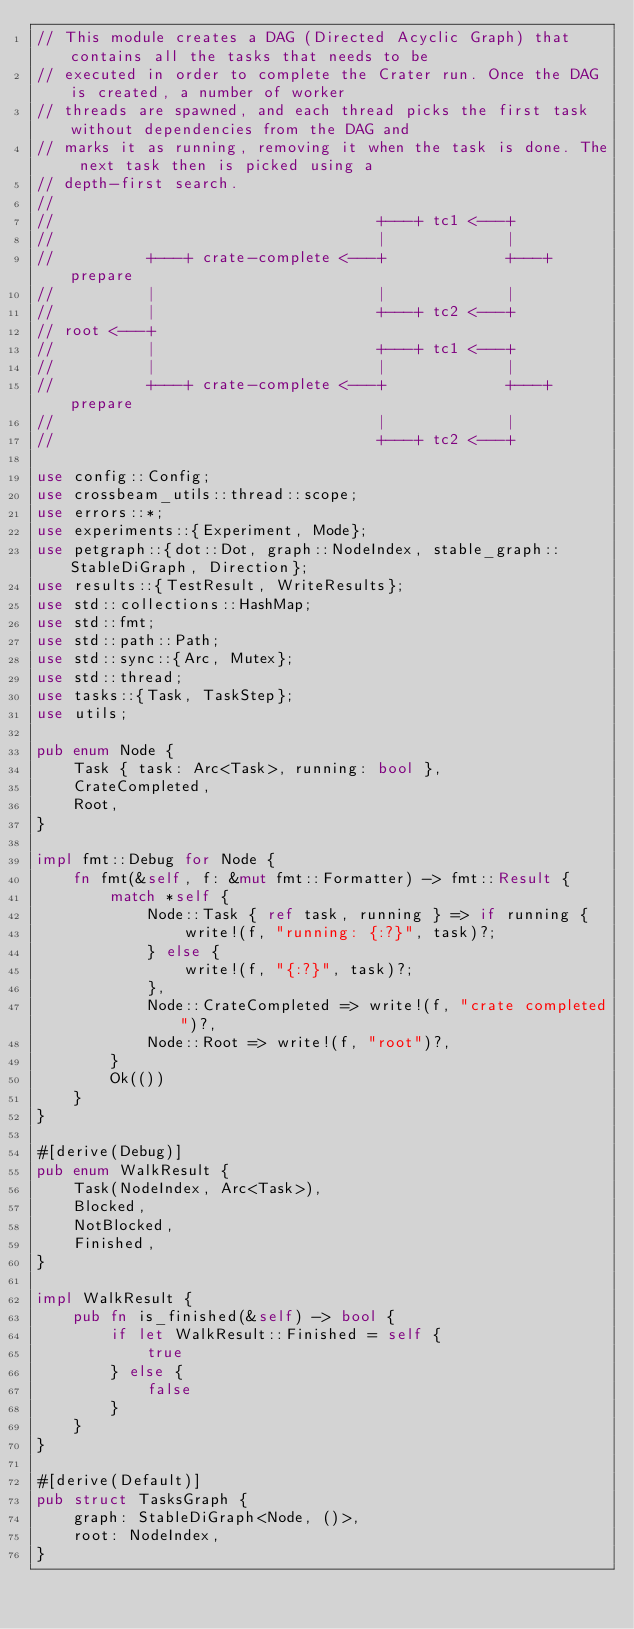<code> <loc_0><loc_0><loc_500><loc_500><_Rust_>// This module creates a DAG (Directed Acyclic Graph) that contains all the tasks that needs to be
// executed in order to complete the Crater run. Once the DAG is created, a number of worker
// threads are spawned, and each thread picks the first task without dependencies from the DAG and
// marks it as running, removing it when the task is done. The next task then is picked using a
// depth-first search.
//
//                                   +---+ tc1 <---+
//                                   |             |
//          +---+ crate-complete <---+             +---+ prepare
//          |                        |             |
//          |                        +---+ tc2 <---+
// root <---+
//          |                        +---+ tc1 <---+
//          |                        |             |
//          +---+ crate-complete <---+             +---+ prepare
//                                   |             |
//                                   +---+ tc2 <---+

use config::Config;
use crossbeam_utils::thread::scope;
use errors::*;
use experiments::{Experiment, Mode};
use petgraph::{dot::Dot, graph::NodeIndex, stable_graph::StableDiGraph, Direction};
use results::{TestResult, WriteResults};
use std::collections::HashMap;
use std::fmt;
use std::path::Path;
use std::sync::{Arc, Mutex};
use std::thread;
use tasks::{Task, TaskStep};
use utils;

pub enum Node {
    Task { task: Arc<Task>, running: bool },
    CrateCompleted,
    Root,
}

impl fmt::Debug for Node {
    fn fmt(&self, f: &mut fmt::Formatter) -> fmt::Result {
        match *self {
            Node::Task { ref task, running } => if running {
                write!(f, "running: {:?}", task)?;
            } else {
                write!(f, "{:?}", task)?;
            },
            Node::CrateCompleted => write!(f, "crate completed")?,
            Node::Root => write!(f, "root")?,
        }
        Ok(())
    }
}

#[derive(Debug)]
pub enum WalkResult {
    Task(NodeIndex, Arc<Task>),
    Blocked,
    NotBlocked,
    Finished,
}

impl WalkResult {
    pub fn is_finished(&self) -> bool {
        if let WalkResult::Finished = self {
            true
        } else {
            false
        }
    }
}

#[derive(Default)]
pub struct TasksGraph {
    graph: StableDiGraph<Node, ()>,
    root: NodeIndex,
}
</code> 